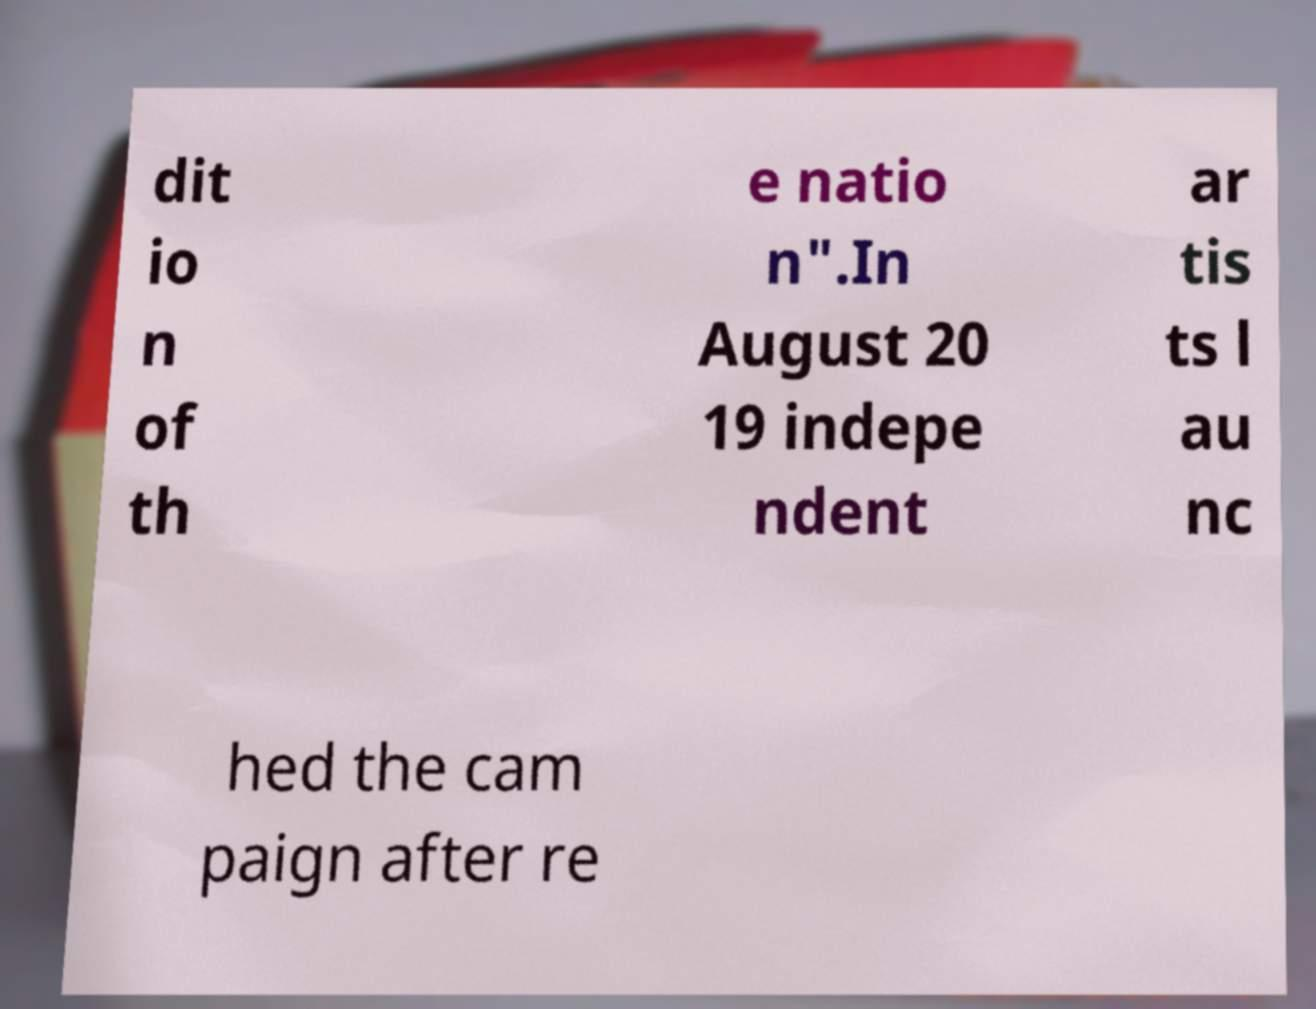Could you assist in decoding the text presented in this image and type it out clearly? dit io n of th e natio n".In August 20 19 indepe ndent ar tis ts l au nc hed the cam paign after re 